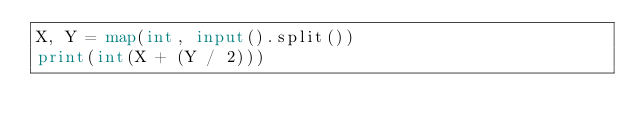<code> <loc_0><loc_0><loc_500><loc_500><_Python_>X, Y = map(int, input().split())
print(int(X + (Y / 2)))</code> 